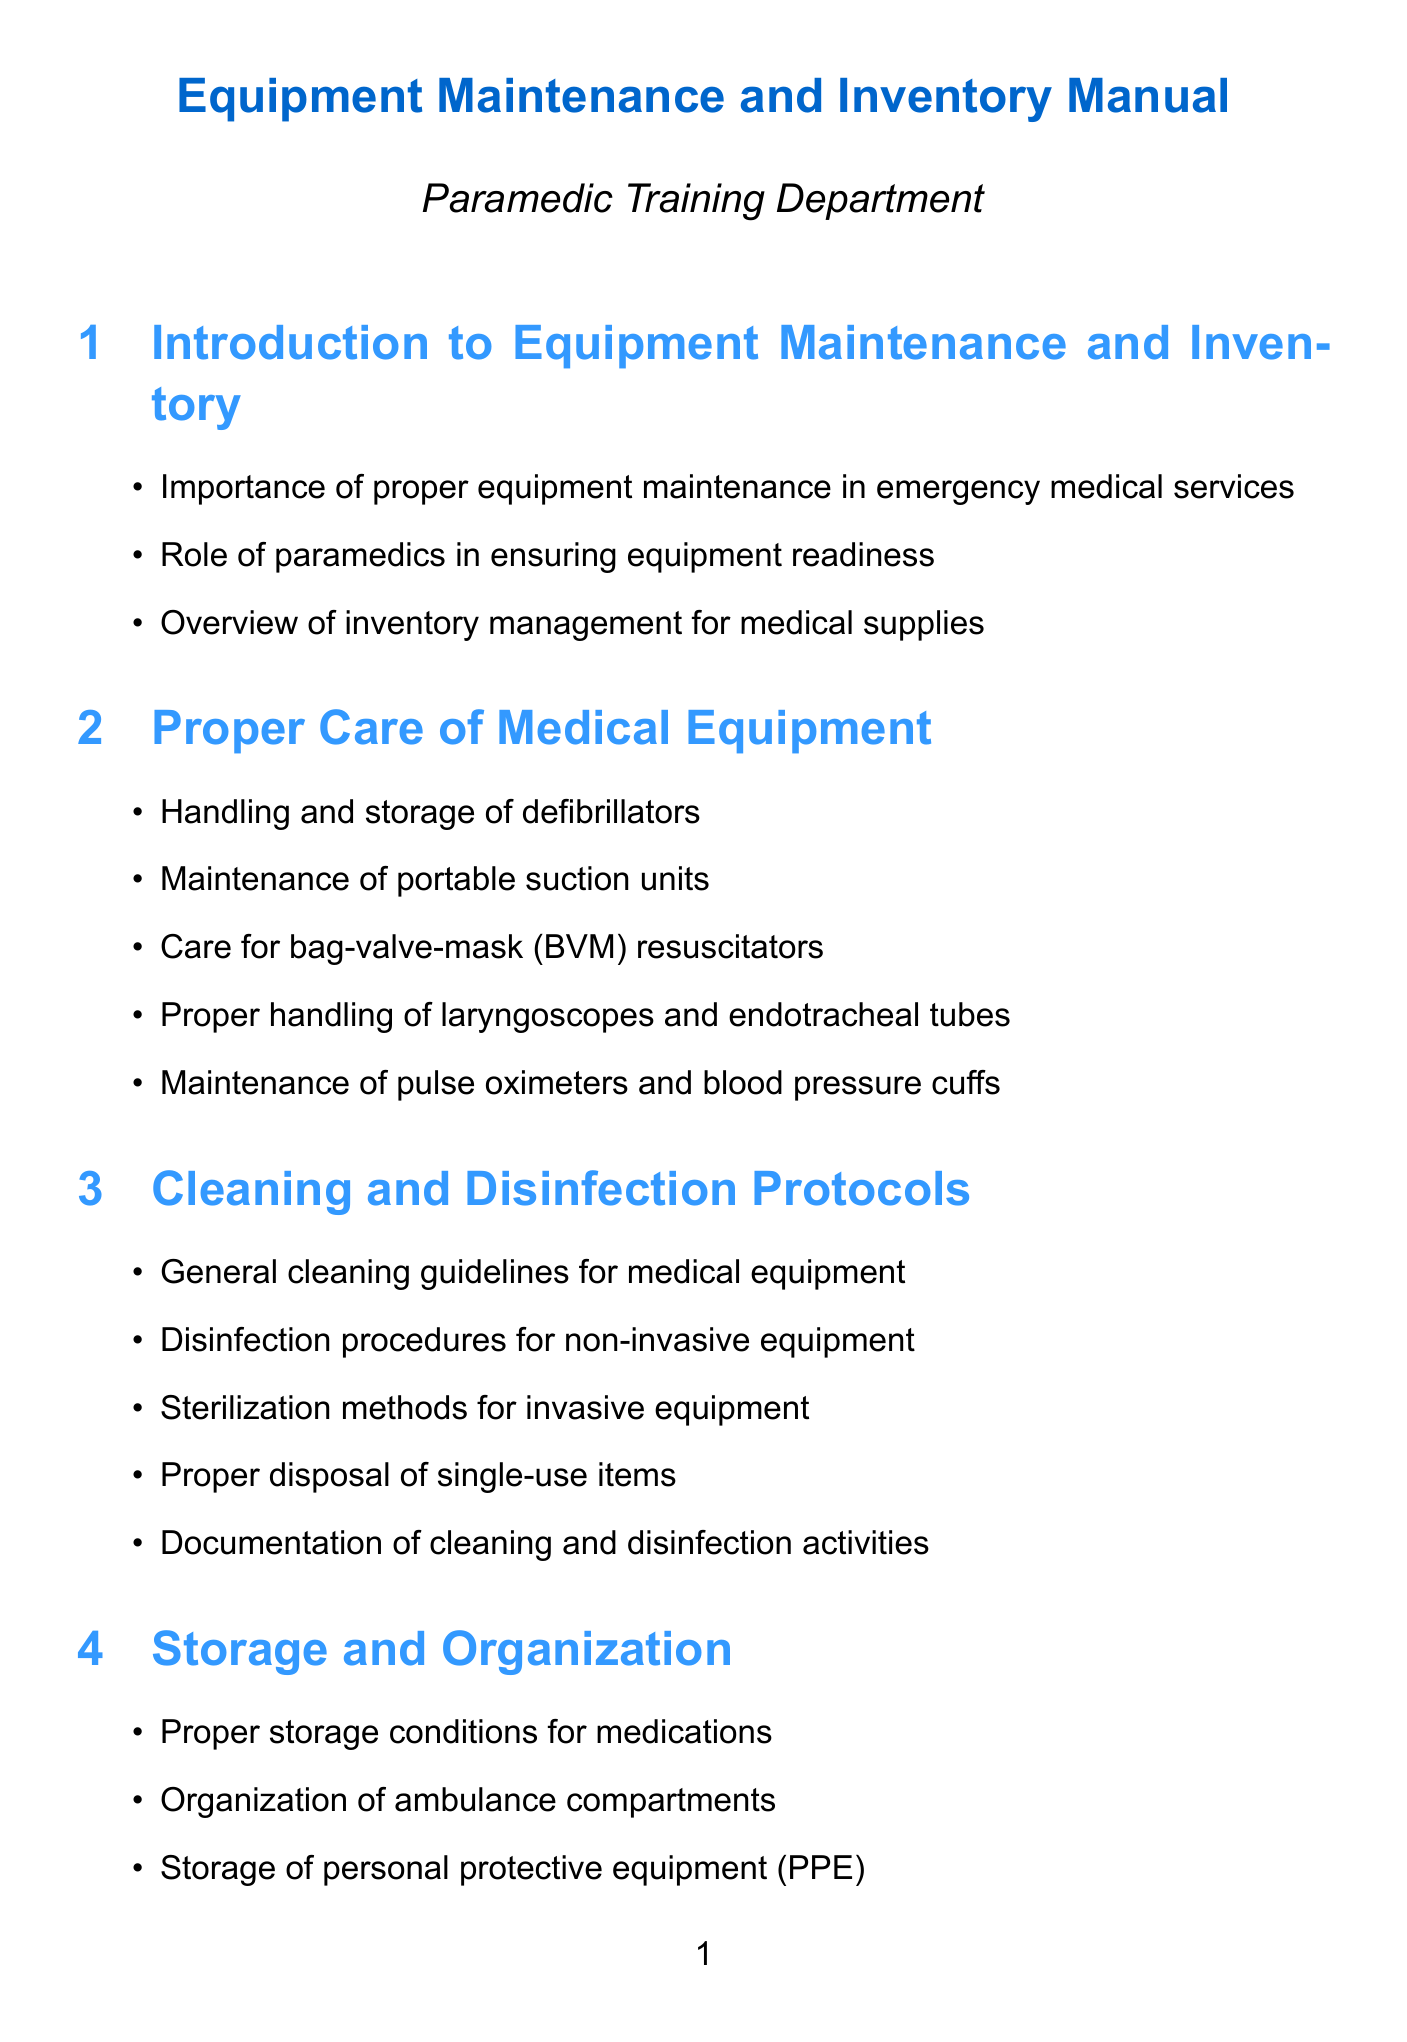what is the title of the manual? The title of the manual is found at the beginning of the document.
Answer: Equipment Maintenance and Inventory Manual how many sections are in the manual? The number of sections is determined by counting the distinct main topics listed in the manual.
Answer: 10 what is included in the daily checklist? The daily checklist contains specific tasks that must be completed every day, as listed in the document.
Answer: Verify oxygen tank levels what is the main focus of the "Safety Considerations" section? The "Safety Considerations" section emphasizes important safety protocols related to equipment maintenance activities.
Answer: Personal protective equipment which section covers the cleaning of medical equipment? The section that specifically addresses the cleaning protocols for medical equipment is indicated in the title.
Answer: Cleaning and Disinfection Protocols how often should a full inventory audit be conducted? The frequency of conducting a full inventory audit is specified in the checklist section of the document.
Answer: Monthly which device is mentioned for troubleshooting in the manual? The manual lists various devices that may have troubleshooting issues, found in the respective section.
Answer: Cardiac monitors what is the purpose of maintaining service logs? The reason for maintaining service logs is elaborated in the documentation section, focusing on compliance and tracking.
Answer: Equipment tracking which items require proper disposal according to the manual? The manual specifies particular items that must be properly disposed of in the cleaning and disinfection protocols section.
Answer: Single-use items 